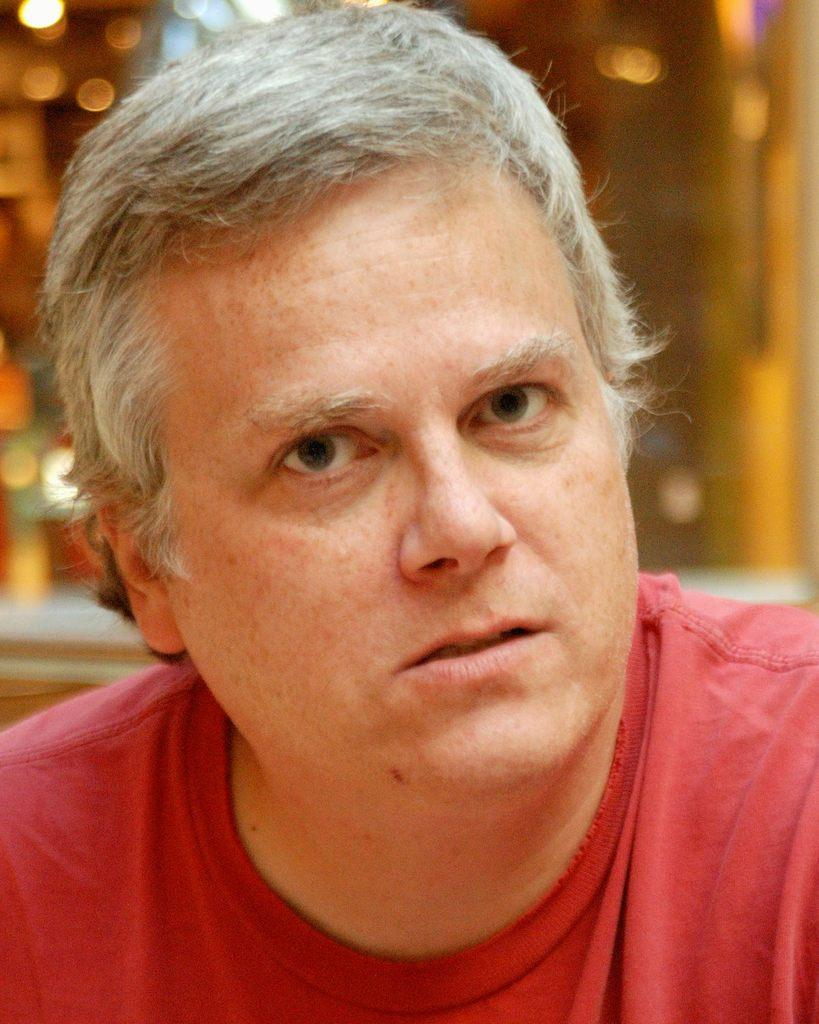Who is the main subject in the image? There is a man in the center of the image. What is the man wearing in the image? The man is wearing a red shirt. What can be seen in the background of the image? There are lights in the background of the image. What statement does the committee make about the man's knowledge in the image? There is no committee present in the image, and therefore no statement can be made about the man's knowledge. 